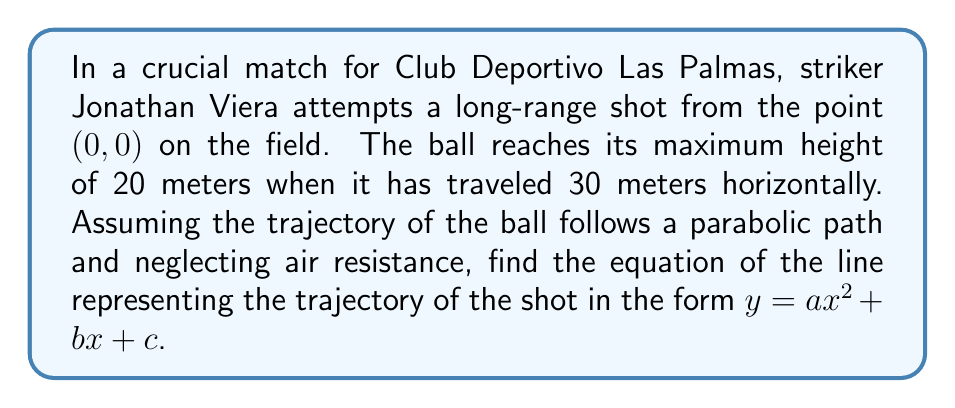Teach me how to tackle this problem. Let's approach this step-by-step:

1) The general form of a parabola is $y = ax^2 + bx + c$, where $a$, $b$, and $c$ are constants we need to determine.

2) We know three points on this parabola:
   - The starting point: (0, 0)
   - The highest point: (30, 20)
   - Another point on the x-axis: (x, 0) where x is unknown

3) Let's use the starting point (0, 0):
   $0 = a(0)^2 + b(0) + c$
   Therefore, $c = 0$

4) Now our equation is $y = ax^2 + bx$

5) Using the highest point (30, 20):
   $20 = a(30)^2 + b(30)$
   $20 = 900a + 30b$ ... (Equation 1)

6) The axis of symmetry of the parabola passes through the highest point, so it's at $x = 30$. The formula for the axis of symmetry is $x = -\frac{b}{2a}$. Therefore:
   $30 = -\frac{b}{2a}$
   $b = -60a$ ... (Equation 2)

7) Substitute Equation 2 into Equation 1:
   $20 = 900a + 30(-60a)$
   $20 = 900a - 1800a$
   $20 = -900a$
   $a = -\frac{1}{45}$

8) Now we can find $b$ using Equation 2:
   $b = -60(-\frac{1}{45}) = \frac{4}{3}$

9) Therefore, the equation of the trajectory is:
   $y = -\frac{1}{45}x^2 + \frac{4}{3}x$
Answer: $y = -\frac{1}{45}x^2 + \frac{4}{3}x$ 